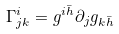Convert formula to latex. <formula><loc_0><loc_0><loc_500><loc_500>\Gamma ^ { i } _ { j k } = g ^ { i \bar { h } } \partial _ { j } g _ { k \bar { h } }</formula> 